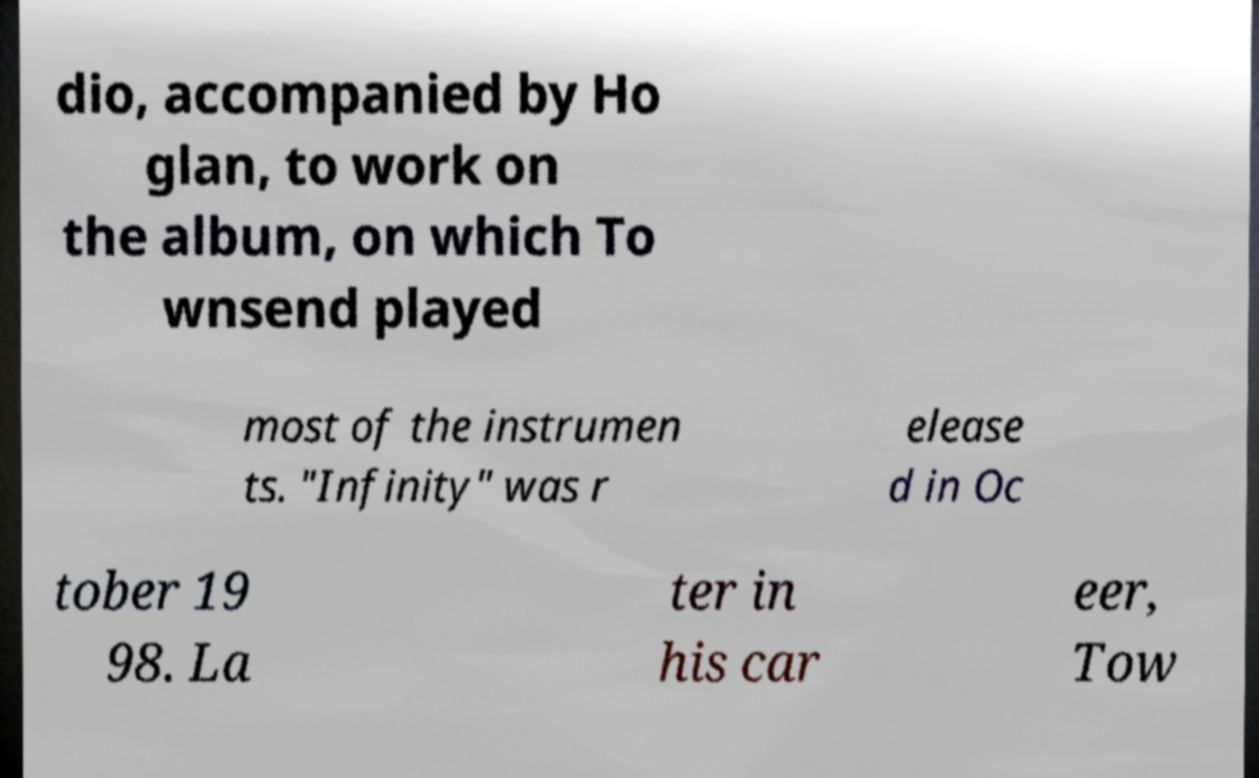Please identify and transcribe the text found in this image. dio, accompanied by Ho glan, to work on the album, on which To wnsend played most of the instrumen ts. "Infinity" was r elease d in Oc tober 19 98. La ter in his car eer, Tow 